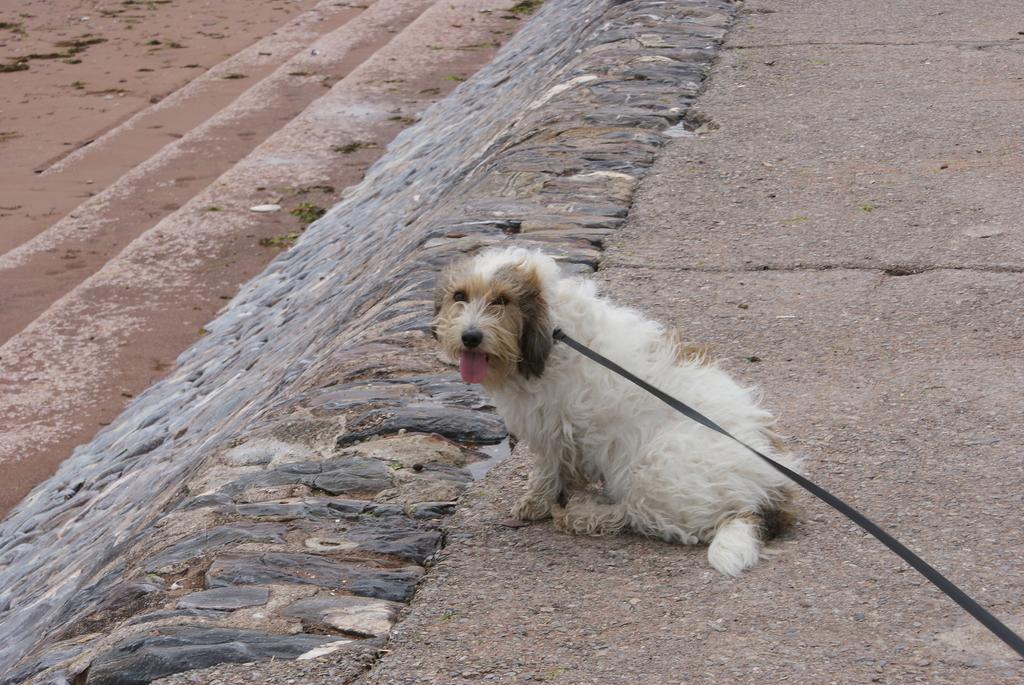Describe this image in one or two sentences. In the center of the image we can see a dog. At the bottom there is a road. 